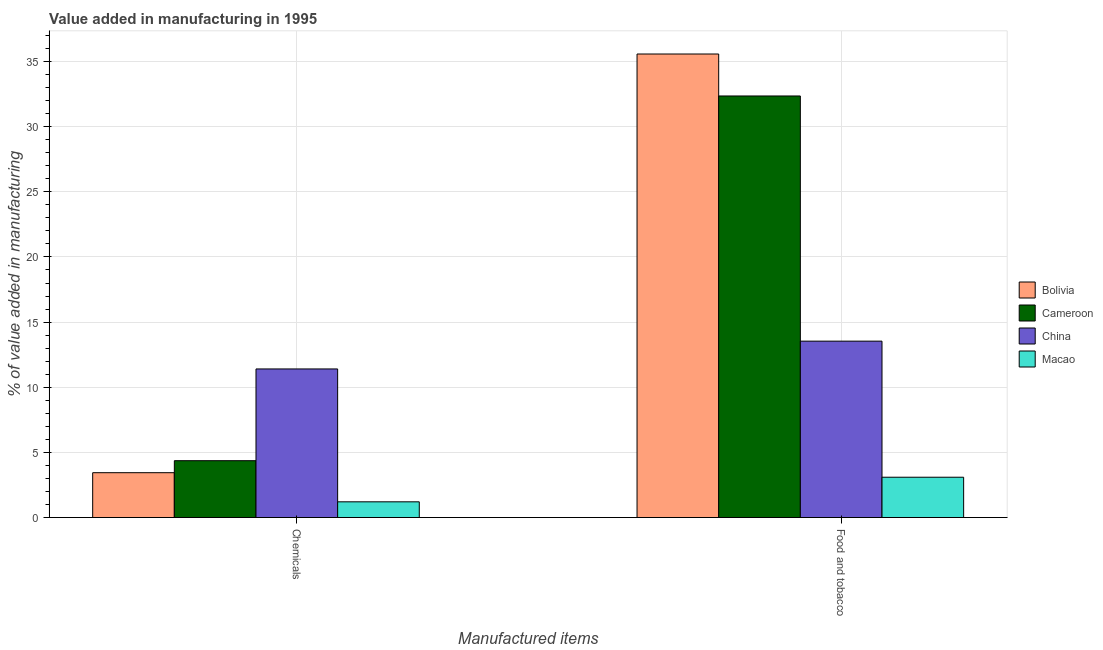How many different coloured bars are there?
Give a very brief answer. 4. How many groups of bars are there?
Keep it short and to the point. 2. What is the label of the 2nd group of bars from the left?
Your answer should be very brief. Food and tobacco. What is the value added by  manufacturing chemicals in China?
Make the answer very short. 11.41. Across all countries, what is the maximum value added by  manufacturing chemicals?
Provide a succinct answer. 11.41. Across all countries, what is the minimum value added by  manufacturing chemicals?
Provide a short and direct response. 1.21. In which country was the value added by manufacturing food and tobacco maximum?
Your response must be concise. Bolivia. In which country was the value added by  manufacturing chemicals minimum?
Provide a short and direct response. Macao. What is the total value added by manufacturing food and tobacco in the graph?
Provide a succinct answer. 84.57. What is the difference between the value added by manufacturing food and tobacco in Cameroon and that in China?
Your response must be concise. 18.82. What is the difference between the value added by  manufacturing chemicals in Bolivia and the value added by manufacturing food and tobacco in China?
Your answer should be compact. -10.1. What is the average value added by manufacturing food and tobacco per country?
Keep it short and to the point. 21.14. What is the difference between the value added by manufacturing food and tobacco and value added by  manufacturing chemicals in Cameroon?
Make the answer very short. 27.99. In how many countries, is the value added by  manufacturing chemicals greater than 25 %?
Your answer should be compact. 0. What is the ratio of the value added by  manufacturing chemicals in Macao to that in Cameroon?
Give a very brief answer. 0.28. Is the value added by  manufacturing chemicals in China less than that in Bolivia?
Keep it short and to the point. No. What does the 1st bar from the left in Chemicals represents?
Offer a terse response. Bolivia. What does the 1st bar from the right in Food and tobacco represents?
Give a very brief answer. Macao. Are all the bars in the graph horizontal?
Offer a very short reply. No. What is the difference between two consecutive major ticks on the Y-axis?
Offer a terse response. 5. Where does the legend appear in the graph?
Provide a short and direct response. Center right. How many legend labels are there?
Offer a terse response. 4. How are the legend labels stacked?
Offer a very short reply. Vertical. What is the title of the graph?
Provide a short and direct response. Value added in manufacturing in 1995. What is the label or title of the X-axis?
Your answer should be compact. Manufactured items. What is the label or title of the Y-axis?
Your answer should be very brief. % of value added in manufacturing. What is the % of value added in manufacturing of Bolivia in Chemicals?
Provide a succinct answer. 3.44. What is the % of value added in manufacturing of Cameroon in Chemicals?
Provide a short and direct response. 4.36. What is the % of value added in manufacturing in China in Chemicals?
Keep it short and to the point. 11.41. What is the % of value added in manufacturing in Macao in Chemicals?
Ensure brevity in your answer.  1.21. What is the % of value added in manufacturing of Bolivia in Food and tobacco?
Your answer should be very brief. 35.58. What is the % of value added in manufacturing of Cameroon in Food and tobacco?
Give a very brief answer. 32.36. What is the % of value added in manufacturing of China in Food and tobacco?
Ensure brevity in your answer.  13.54. What is the % of value added in manufacturing of Macao in Food and tobacco?
Provide a short and direct response. 3.1. Across all Manufactured items, what is the maximum % of value added in manufacturing in Bolivia?
Provide a succinct answer. 35.58. Across all Manufactured items, what is the maximum % of value added in manufacturing in Cameroon?
Provide a succinct answer. 32.36. Across all Manufactured items, what is the maximum % of value added in manufacturing in China?
Offer a terse response. 13.54. Across all Manufactured items, what is the maximum % of value added in manufacturing in Macao?
Your answer should be very brief. 3.1. Across all Manufactured items, what is the minimum % of value added in manufacturing in Bolivia?
Ensure brevity in your answer.  3.44. Across all Manufactured items, what is the minimum % of value added in manufacturing in Cameroon?
Your answer should be very brief. 4.36. Across all Manufactured items, what is the minimum % of value added in manufacturing of China?
Provide a short and direct response. 11.41. Across all Manufactured items, what is the minimum % of value added in manufacturing of Macao?
Make the answer very short. 1.21. What is the total % of value added in manufacturing in Bolivia in the graph?
Keep it short and to the point. 39.02. What is the total % of value added in manufacturing in Cameroon in the graph?
Make the answer very short. 36.72. What is the total % of value added in manufacturing of China in the graph?
Your response must be concise. 24.95. What is the total % of value added in manufacturing in Macao in the graph?
Your response must be concise. 4.3. What is the difference between the % of value added in manufacturing of Bolivia in Chemicals and that in Food and tobacco?
Your answer should be compact. -32.13. What is the difference between the % of value added in manufacturing in Cameroon in Chemicals and that in Food and tobacco?
Keep it short and to the point. -27.99. What is the difference between the % of value added in manufacturing in China in Chemicals and that in Food and tobacco?
Keep it short and to the point. -2.13. What is the difference between the % of value added in manufacturing in Macao in Chemicals and that in Food and tobacco?
Provide a succinct answer. -1.89. What is the difference between the % of value added in manufacturing in Bolivia in Chemicals and the % of value added in manufacturing in Cameroon in Food and tobacco?
Your answer should be compact. -28.91. What is the difference between the % of value added in manufacturing of Bolivia in Chemicals and the % of value added in manufacturing of China in Food and tobacco?
Your answer should be very brief. -10.1. What is the difference between the % of value added in manufacturing of Bolivia in Chemicals and the % of value added in manufacturing of Macao in Food and tobacco?
Ensure brevity in your answer.  0.35. What is the difference between the % of value added in manufacturing in Cameroon in Chemicals and the % of value added in manufacturing in China in Food and tobacco?
Your answer should be compact. -9.17. What is the difference between the % of value added in manufacturing of Cameroon in Chemicals and the % of value added in manufacturing of Macao in Food and tobacco?
Give a very brief answer. 1.27. What is the difference between the % of value added in manufacturing in China in Chemicals and the % of value added in manufacturing in Macao in Food and tobacco?
Your response must be concise. 8.31. What is the average % of value added in manufacturing in Bolivia per Manufactured items?
Make the answer very short. 19.51. What is the average % of value added in manufacturing in Cameroon per Manufactured items?
Ensure brevity in your answer.  18.36. What is the average % of value added in manufacturing of China per Manufactured items?
Offer a very short reply. 12.47. What is the average % of value added in manufacturing in Macao per Manufactured items?
Make the answer very short. 2.15. What is the difference between the % of value added in manufacturing of Bolivia and % of value added in manufacturing of Cameroon in Chemicals?
Give a very brief answer. -0.92. What is the difference between the % of value added in manufacturing in Bolivia and % of value added in manufacturing in China in Chemicals?
Ensure brevity in your answer.  -7.96. What is the difference between the % of value added in manufacturing in Bolivia and % of value added in manufacturing in Macao in Chemicals?
Provide a short and direct response. 2.24. What is the difference between the % of value added in manufacturing of Cameroon and % of value added in manufacturing of China in Chemicals?
Your response must be concise. -7.04. What is the difference between the % of value added in manufacturing in Cameroon and % of value added in manufacturing in Macao in Chemicals?
Keep it short and to the point. 3.16. What is the difference between the % of value added in manufacturing in China and % of value added in manufacturing in Macao in Chemicals?
Offer a terse response. 10.2. What is the difference between the % of value added in manufacturing of Bolivia and % of value added in manufacturing of Cameroon in Food and tobacco?
Offer a terse response. 3.22. What is the difference between the % of value added in manufacturing of Bolivia and % of value added in manufacturing of China in Food and tobacco?
Ensure brevity in your answer.  22.04. What is the difference between the % of value added in manufacturing in Bolivia and % of value added in manufacturing in Macao in Food and tobacco?
Ensure brevity in your answer.  32.48. What is the difference between the % of value added in manufacturing in Cameroon and % of value added in manufacturing in China in Food and tobacco?
Offer a terse response. 18.82. What is the difference between the % of value added in manufacturing in Cameroon and % of value added in manufacturing in Macao in Food and tobacco?
Make the answer very short. 29.26. What is the difference between the % of value added in manufacturing of China and % of value added in manufacturing of Macao in Food and tobacco?
Offer a terse response. 10.44. What is the ratio of the % of value added in manufacturing in Bolivia in Chemicals to that in Food and tobacco?
Make the answer very short. 0.1. What is the ratio of the % of value added in manufacturing in Cameroon in Chemicals to that in Food and tobacco?
Your answer should be very brief. 0.13. What is the ratio of the % of value added in manufacturing of China in Chemicals to that in Food and tobacco?
Provide a succinct answer. 0.84. What is the ratio of the % of value added in manufacturing in Macao in Chemicals to that in Food and tobacco?
Your response must be concise. 0.39. What is the difference between the highest and the second highest % of value added in manufacturing of Bolivia?
Your answer should be compact. 32.13. What is the difference between the highest and the second highest % of value added in manufacturing of Cameroon?
Provide a succinct answer. 27.99. What is the difference between the highest and the second highest % of value added in manufacturing of China?
Provide a short and direct response. 2.13. What is the difference between the highest and the second highest % of value added in manufacturing in Macao?
Ensure brevity in your answer.  1.89. What is the difference between the highest and the lowest % of value added in manufacturing of Bolivia?
Your answer should be compact. 32.13. What is the difference between the highest and the lowest % of value added in manufacturing of Cameroon?
Make the answer very short. 27.99. What is the difference between the highest and the lowest % of value added in manufacturing of China?
Make the answer very short. 2.13. What is the difference between the highest and the lowest % of value added in manufacturing in Macao?
Keep it short and to the point. 1.89. 